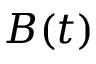<formula> <loc_0><loc_0><loc_500><loc_500>B ( t )</formula> 